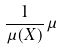<formula> <loc_0><loc_0><loc_500><loc_500>\frac { 1 } { \mu ( X ) } \mu</formula> 